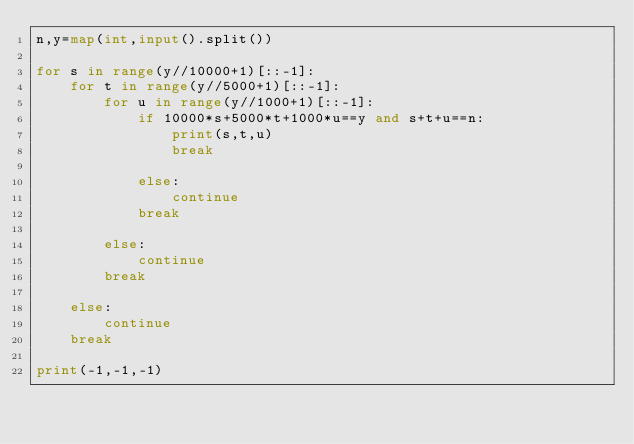<code> <loc_0><loc_0><loc_500><loc_500><_Python_>n,y=map(int,input().split())

for s in range(y//10000+1)[::-1]:
    for t in range(y//5000+1)[::-1]:
        for u in range(y//1000+1)[::-1]:
            if 10000*s+5000*t+1000*u==y and s+t+u==n:
                print(s,t,u)
                break
                
            else:
                continue
            break
            
        else:
            continue
        break
        
    else:
        continue
    break
    
print(-1,-1,-1)</code> 